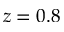Convert formula to latex. <formula><loc_0><loc_0><loc_500><loc_500>z = 0 . 8</formula> 